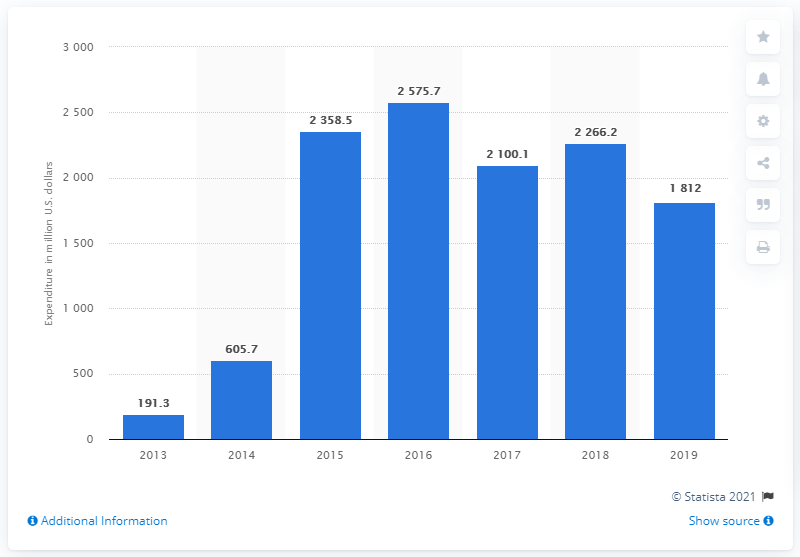Point out several critical features in this image. In 2019, Allergan invested 1812 in research and development. 